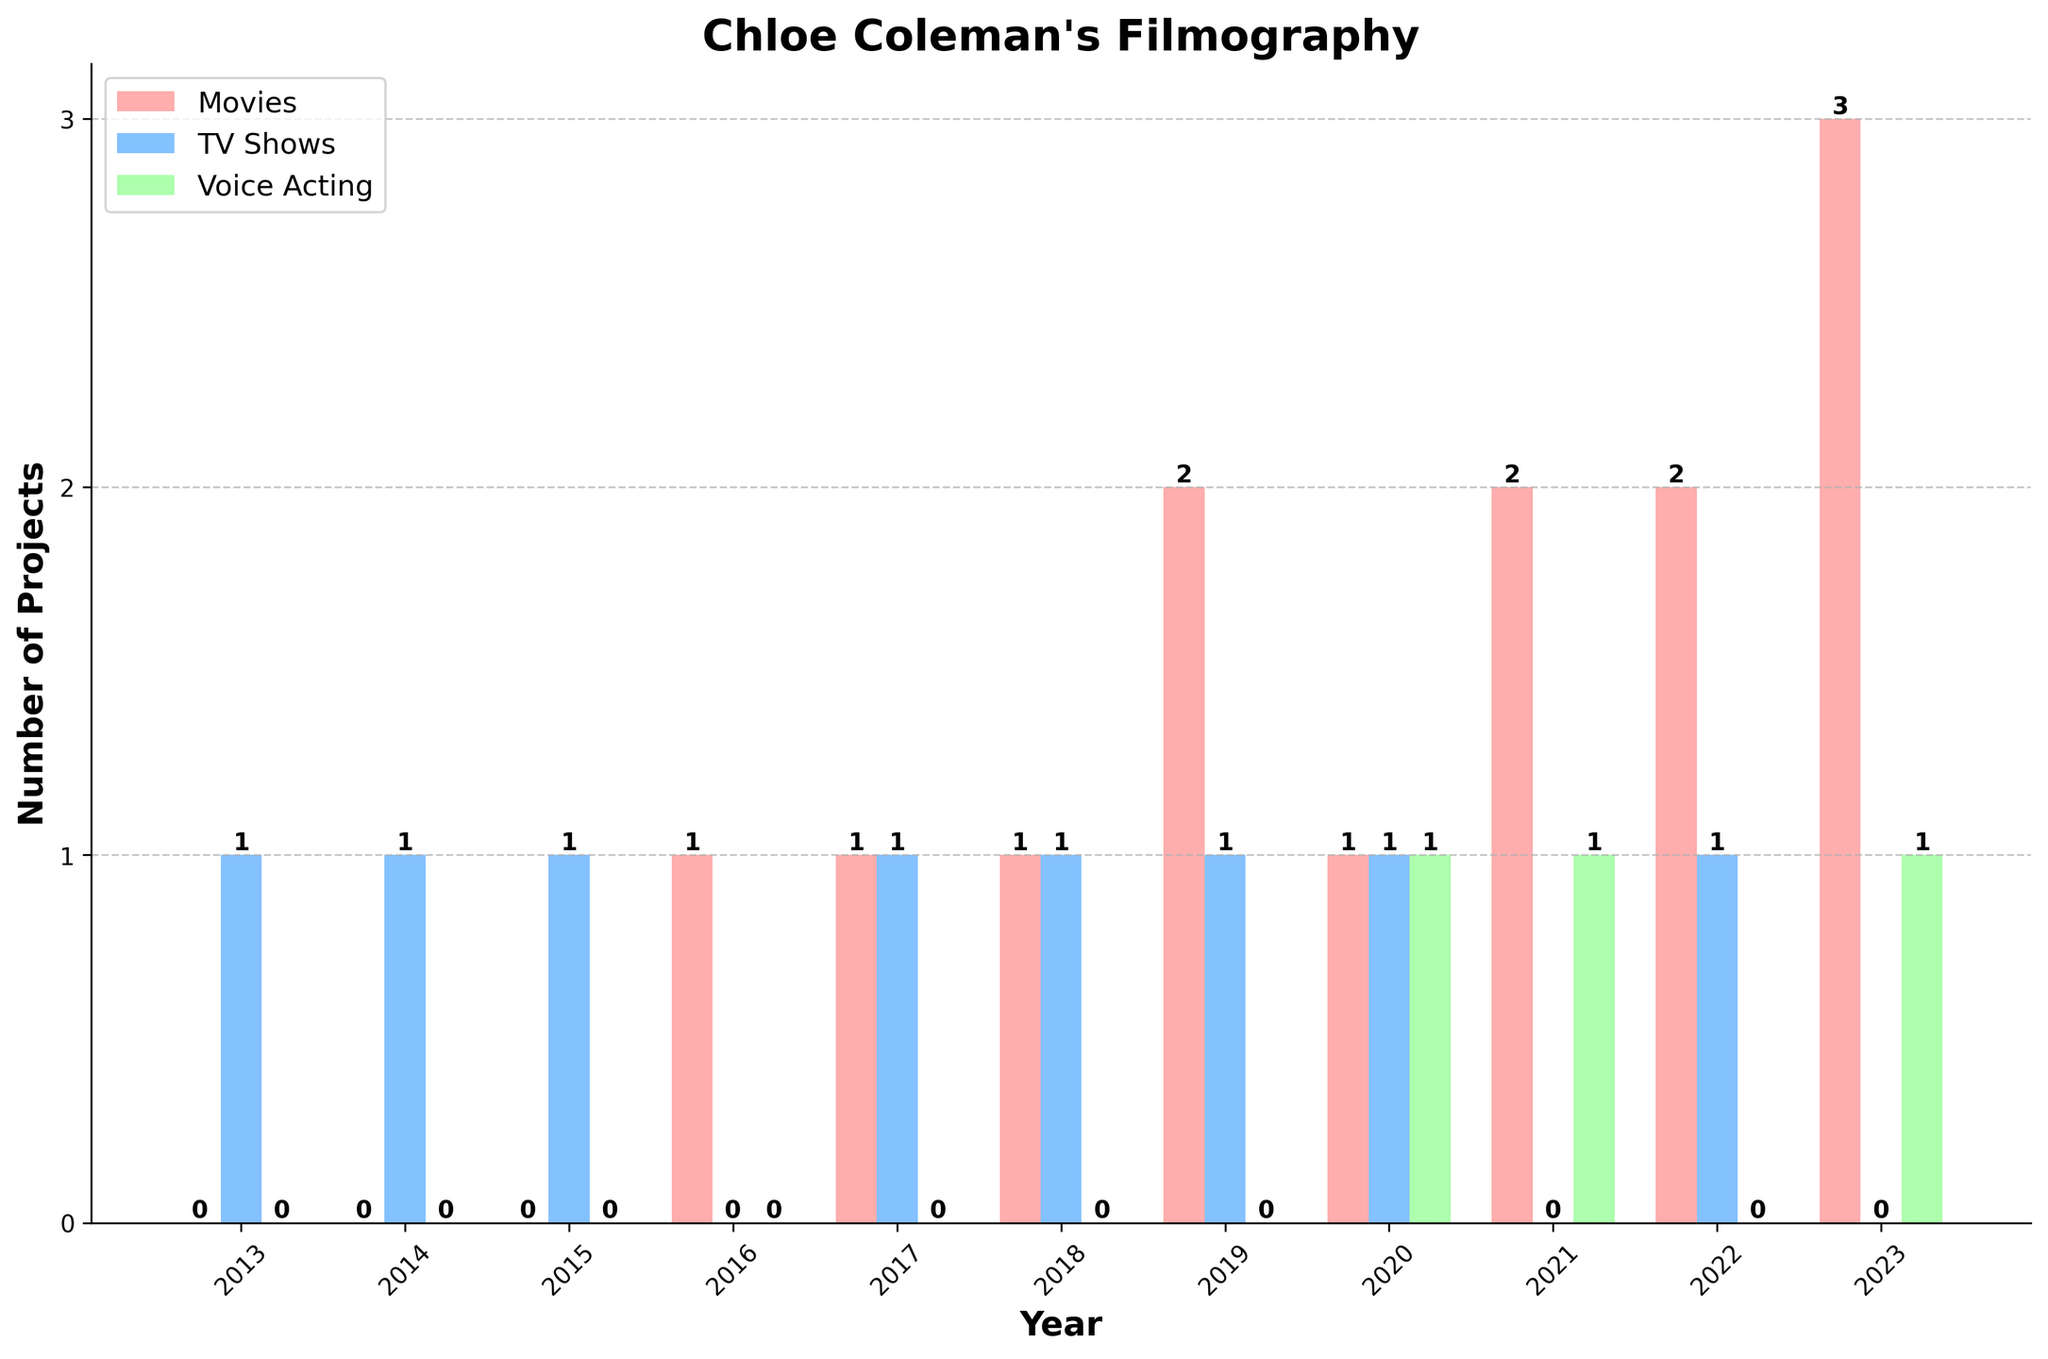How many movies did Chloe Coleman work on in 2023? Look at the bar for the year 2023 and identify the bar labeled "Movies." The height represents the number of projects, which is 3.
Answer: 3 In which year did Chloe Coleman participate in the highest number of projects in total? Sum the projects for each type (Movies, TV Shows, Voice Acting) for each year. The year with the highest sum is 2023 with 4 projects (3 movies and 1 voice acting).
Answer: 2023 Compare the number of TV shows Chloe Coleman participated in between 2013 and 2023. Which year had more TV shows? Locate the TV shows bar for each year and compare their heights. Both 2013 and 2023 have 0 TV shows, so there's no difference.
Answer: Equal Which type of project has Chloe Coleman done the least of over the years? Sum up the total number of each project type (Movies, TV Shows, Voice Acting) across all years: Movies (13), TV Shows (8), Voice Acting (3). Voice Acting is the least.
Answer: Voice Acting How many total projects did Chloe Coleman work on in 2020? Sum the number of projects for 2020: 1 movie, 1 TV show, and 1 voice acting. The total is 1+1+1=3.
Answer: 3 What is the difference in the number of movies between 2019 and 2022? Locate the movie bars for 2019 and 2022. In 2019, there are 2 movies, and in 2022 there are also 2. The difference is 0.
Answer: 0 Which year shows the first instance of Chloe Coleman participating in a voice acting project? Examine each year's bar for voice acting and find the earliest one. The first instance is in 2020.
Answer: 2020 Between 2017 and 2019, which year had the maximum number of TV shows? Compare the TV show bars for 2017, 2018, and 2019. Each year has 1 TV show, so they are equal.
Answer: Equal What is the average number of TV shows Chloe Coleman participated in per year from 2013 to 2023? Calculate the total TV shows (8) and divide by the number of years (11): 8 / 11 ≈ 0.73.
Answer: 0.73 In which year did Chloe Coleman participate in an equal number of movies and TV shows? Compare the heights of the bars for movies and TV shows within the same year. The year 2018 has 1 movie and 1 TV show, making them equal.
Answer: 2018 